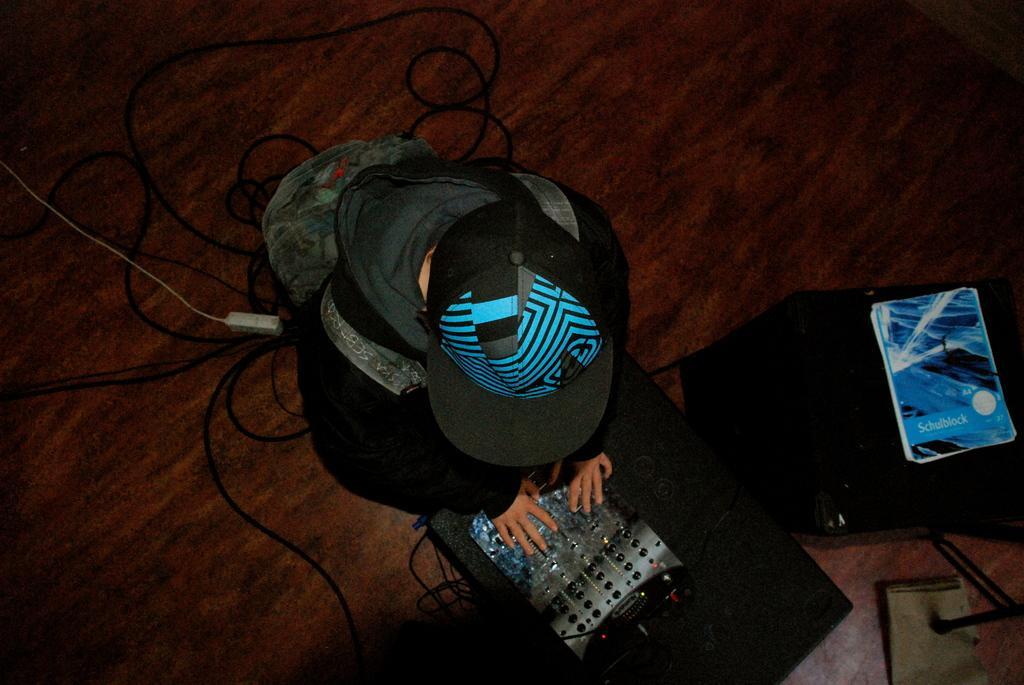Can you describe this image briefly? There is one person wearing a black color dress and a hat in the middle of this image. There is a electronic device at the bottom of this image and which is connected with some wires. There is one book kept on a black color bag on the right side of this image. 